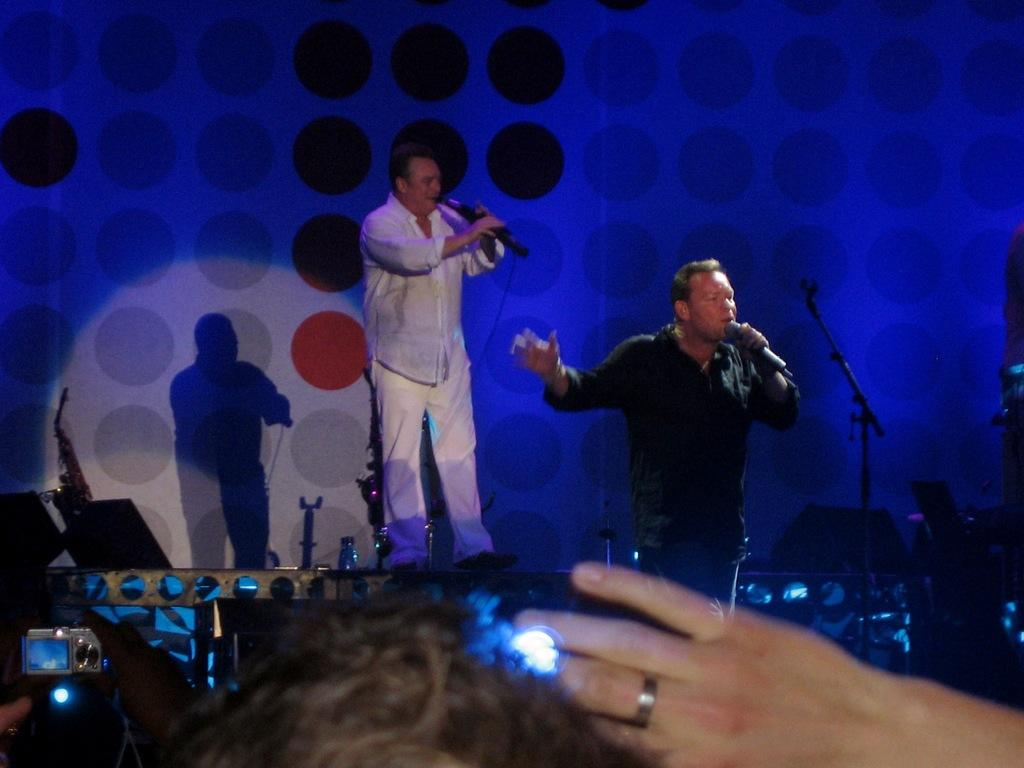How many people are in the image? There are two men in the image. What are the men doing in the image? The men are standing and holding microphones. What color light is present in the image? There is blue color light in the image. Can you describe any shadows in the image? There is a shadow of a man on the wall. What type of food is being served in the lunchroom in the image? There is no lunchroom or food present in the image; it features two men holding microphones. Can you see any wild animals in the image? There are no wild animals present in the image. 